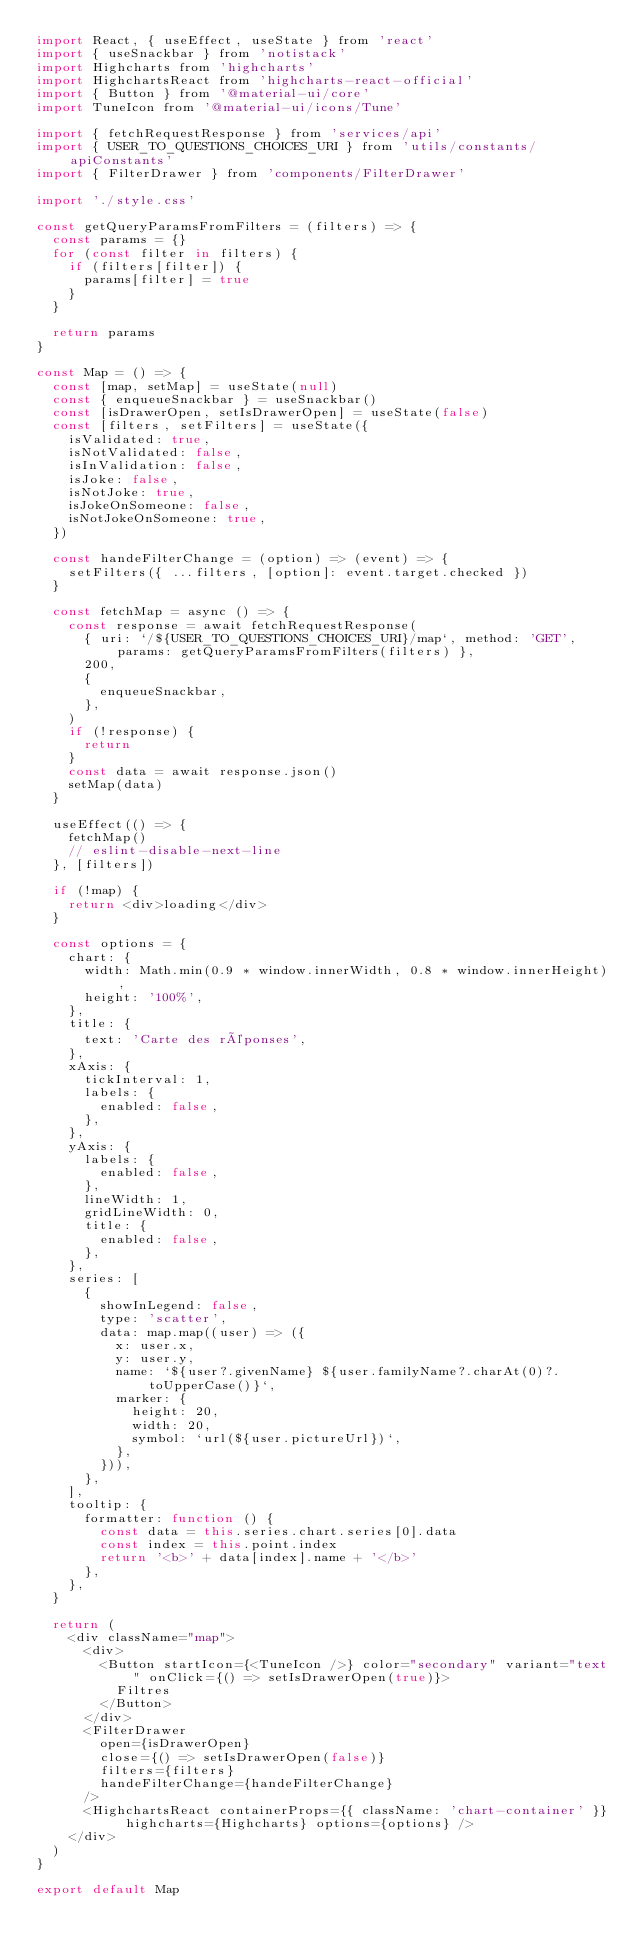<code> <loc_0><loc_0><loc_500><loc_500><_JavaScript_>import React, { useEffect, useState } from 'react'
import { useSnackbar } from 'notistack'
import Highcharts from 'highcharts'
import HighchartsReact from 'highcharts-react-official'
import { Button } from '@material-ui/core'
import TuneIcon from '@material-ui/icons/Tune'

import { fetchRequestResponse } from 'services/api'
import { USER_TO_QUESTIONS_CHOICES_URI } from 'utils/constants/apiConstants'
import { FilterDrawer } from 'components/FilterDrawer'

import './style.css'

const getQueryParamsFromFilters = (filters) => {
  const params = {}
  for (const filter in filters) {
    if (filters[filter]) {
      params[filter] = true
    }
  }

  return params
}

const Map = () => {
  const [map, setMap] = useState(null)
  const { enqueueSnackbar } = useSnackbar()
  const [isDrawerOpen, setIsDrawerOpen] = useState(false)
  const [filters, setFilters] = useState({
    isValidated: true,
    isNotValidated: false,
    isInValidation: false,
    isJoke: false,
    isNotJoke: true,
    isJokeOnSomeone: false,
    isNotJokeOnSomeone: true,
  })

  const handeFilterChange = (option) => (event) => {
    setFilters({ ...filters, [option]: event.target.checked })
  }

  const fetchMap = async () => {
    const response = await fetchRequestResponse(
      { uri: `/${USER_TO_QUESTIONS_CHOICES_URI}/map`, method: 'GET', params: getQueryParamsFromFilters(filters) },
      200,
      {
        enqueueSnackbar,
      },
    )
    if (!response) {
      return
    }
    const data = await response.json()
    setMap(data)
  }

  useEffect(() => {
    fetchMap()
    // eslint-disable-next-line
  }, [filters])

  if (!map) {
    return <div>loading</div>
  }

  const options = {
    chart: {
      width: Math.min(0.9 * window.innerWidth, 0.8 * window.innerHeight),
      height: '100%',
    },
    title: {
      text: 'Carte des réponses',
    },
    xAxis: {
      tickInterval: 1,
      labels: {
        enabled: false,
      },
    },
    yAxis: {
      labels: {
        enabled: false,
      },
      lineWidth: 1,
      gridLineWidth: 0,
      title: {
        enabled: false,
      },
    },
    series: [
      {
        showInLegend: false,
        type: 'scatter',
        data: map.map((user) => ({
          x: user.x,
          y: user.y,
          name: `${user?.givenName} ${user.familyName?.charAt(0)?.toUpperCase()}`,
          marker: {
            height: 20,
            width: 20,
            symbol: `url(${user.pictureUrl})`,
          },
        })),
      },
    ],
    tooltip: {
      formatter: function () {
        const data = this.series.chart.series[0].data
        const index = this.point.index
        return '<b>' + data[index].name + '</b>'
      },
    },
  }

  return (
    <div className="map">
      <div>
        <Button startIcon={<TuneIcon />} color="secondary" variant="text" onClick={() => setIsDrawerOpen(true)}>
          Filtres
        </Button>
      </div>
      <FilterDrawer
        open={isDrawerOpen}
        close={() => setIsDrawerOpen(false)}
        filters={filters}
        handeFilterChange={handeFilterChange}
      />
      <HighchartsReact containerProps={{ className: 'chart-container' }} highcharts={Highcharts} options={options} />
    </div>
  )
}

export default Map
</code> 